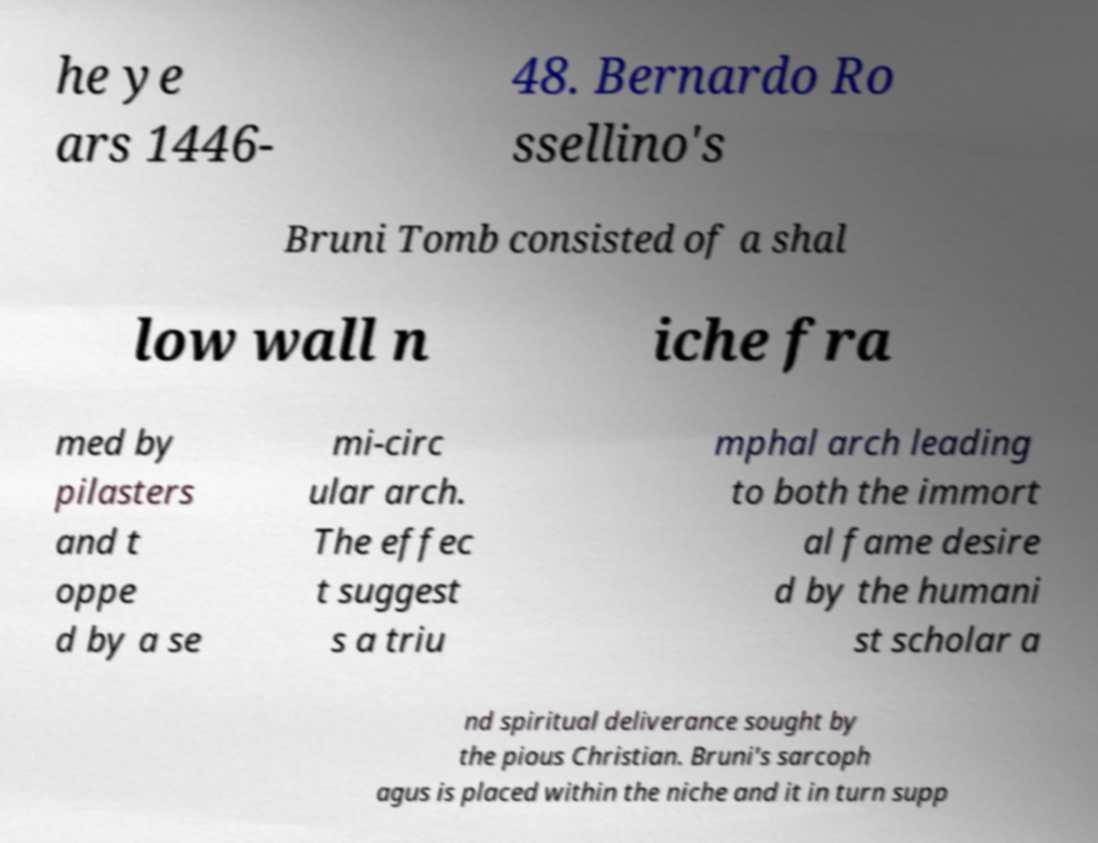Can you accurately transcribe the text from the provided image for me? he ye ars 1446- 48. Bernardo Ro ssellino's Bruni Tomb consisted of a shal low wall n iche fra med by pilasters and t oppe d by a se mi-circ ular arch. The effec t suggest s a triu mphal arch leading to both the immort al fame desire d by the humani st scholar a nd spiritual deliverance sought by the pious Christian. Bruni's sarcoph agus is placed within the niche and it in turn supp 